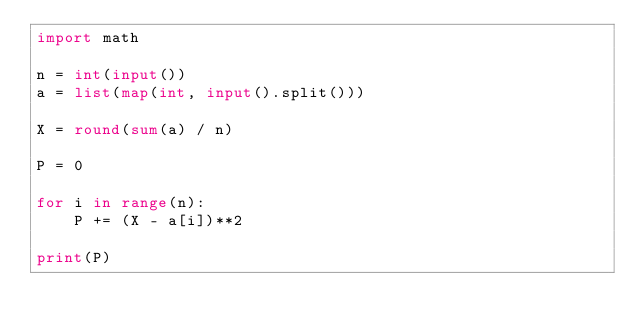<code> <loc_0><loc_0><loc_500><loc_500><_Python_>import math

n = int(input())
a = list(map(int, input().split()))

X = round(sum(a) / n)

P = 0

for i in range(n):
    P += (X - a[i])**2

print(P)</code> 